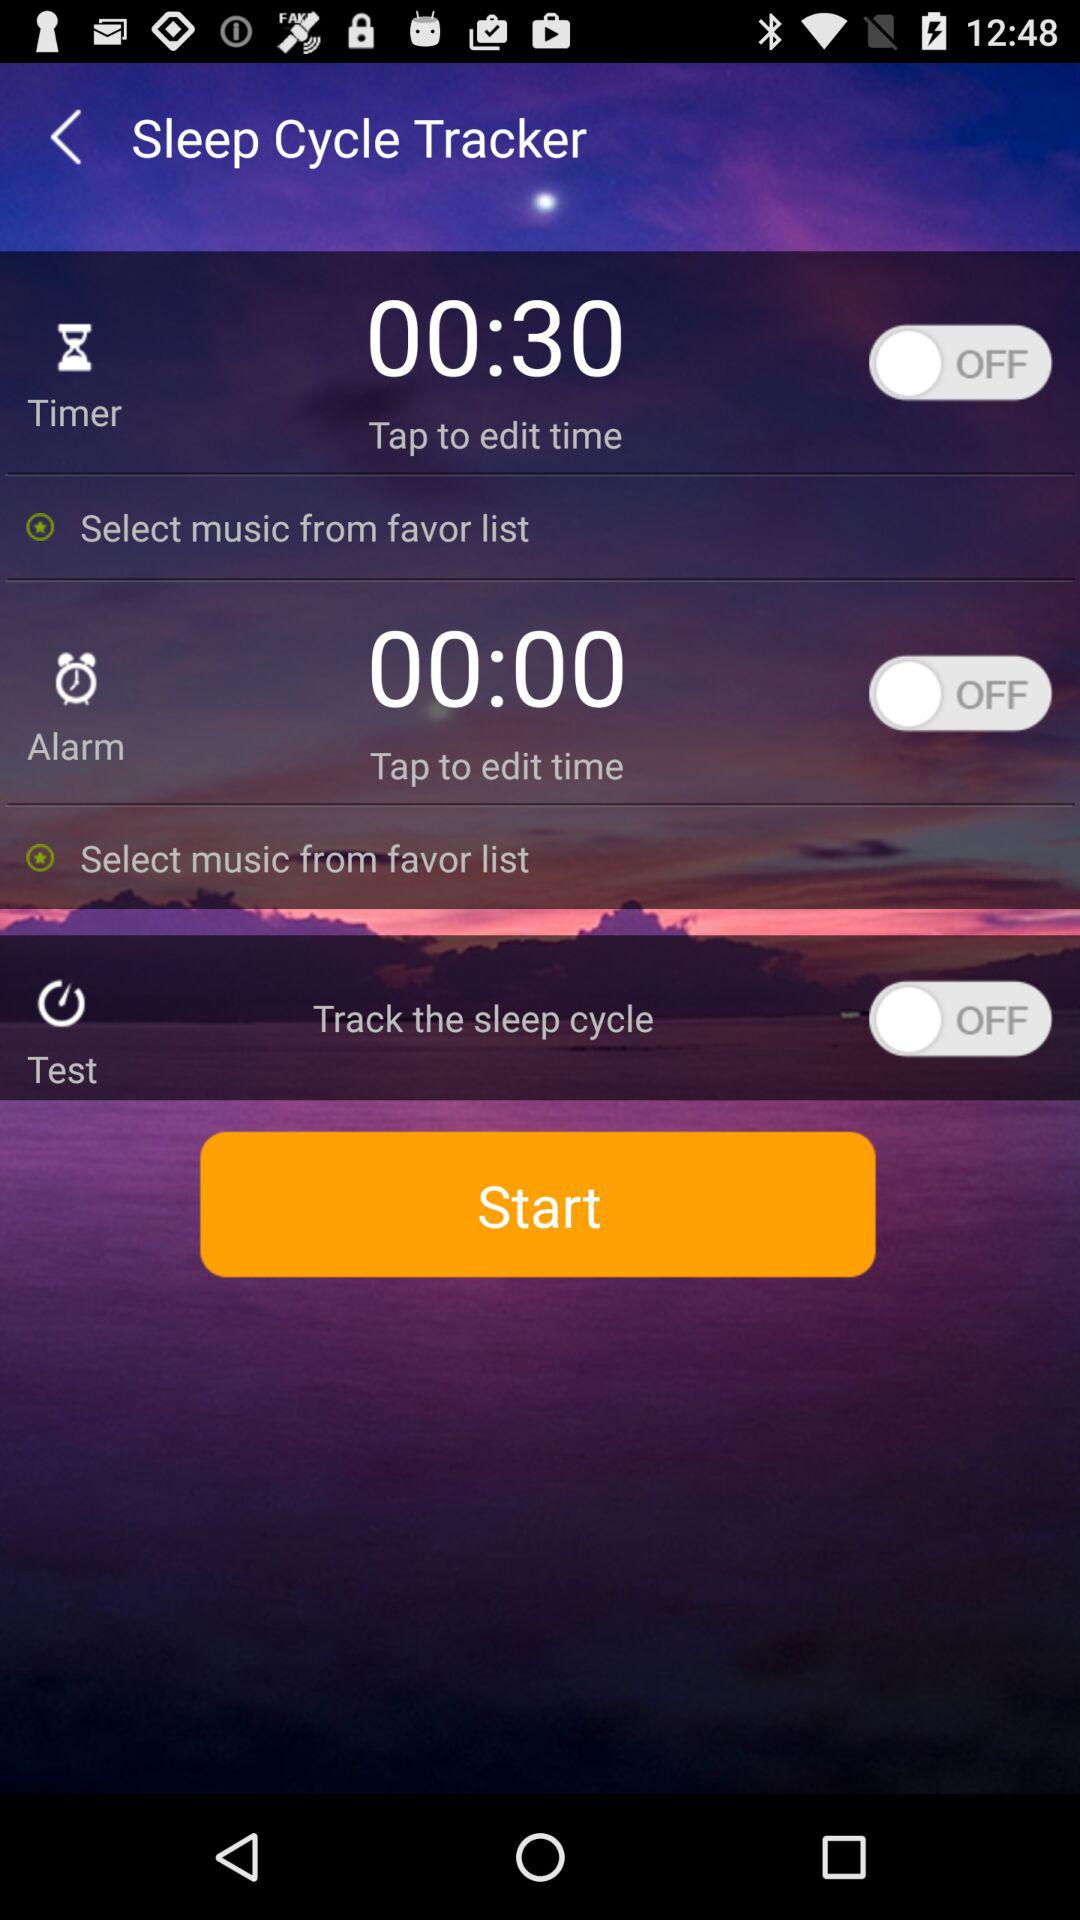What is the duration of the timer? The duration is 30 seconds. 